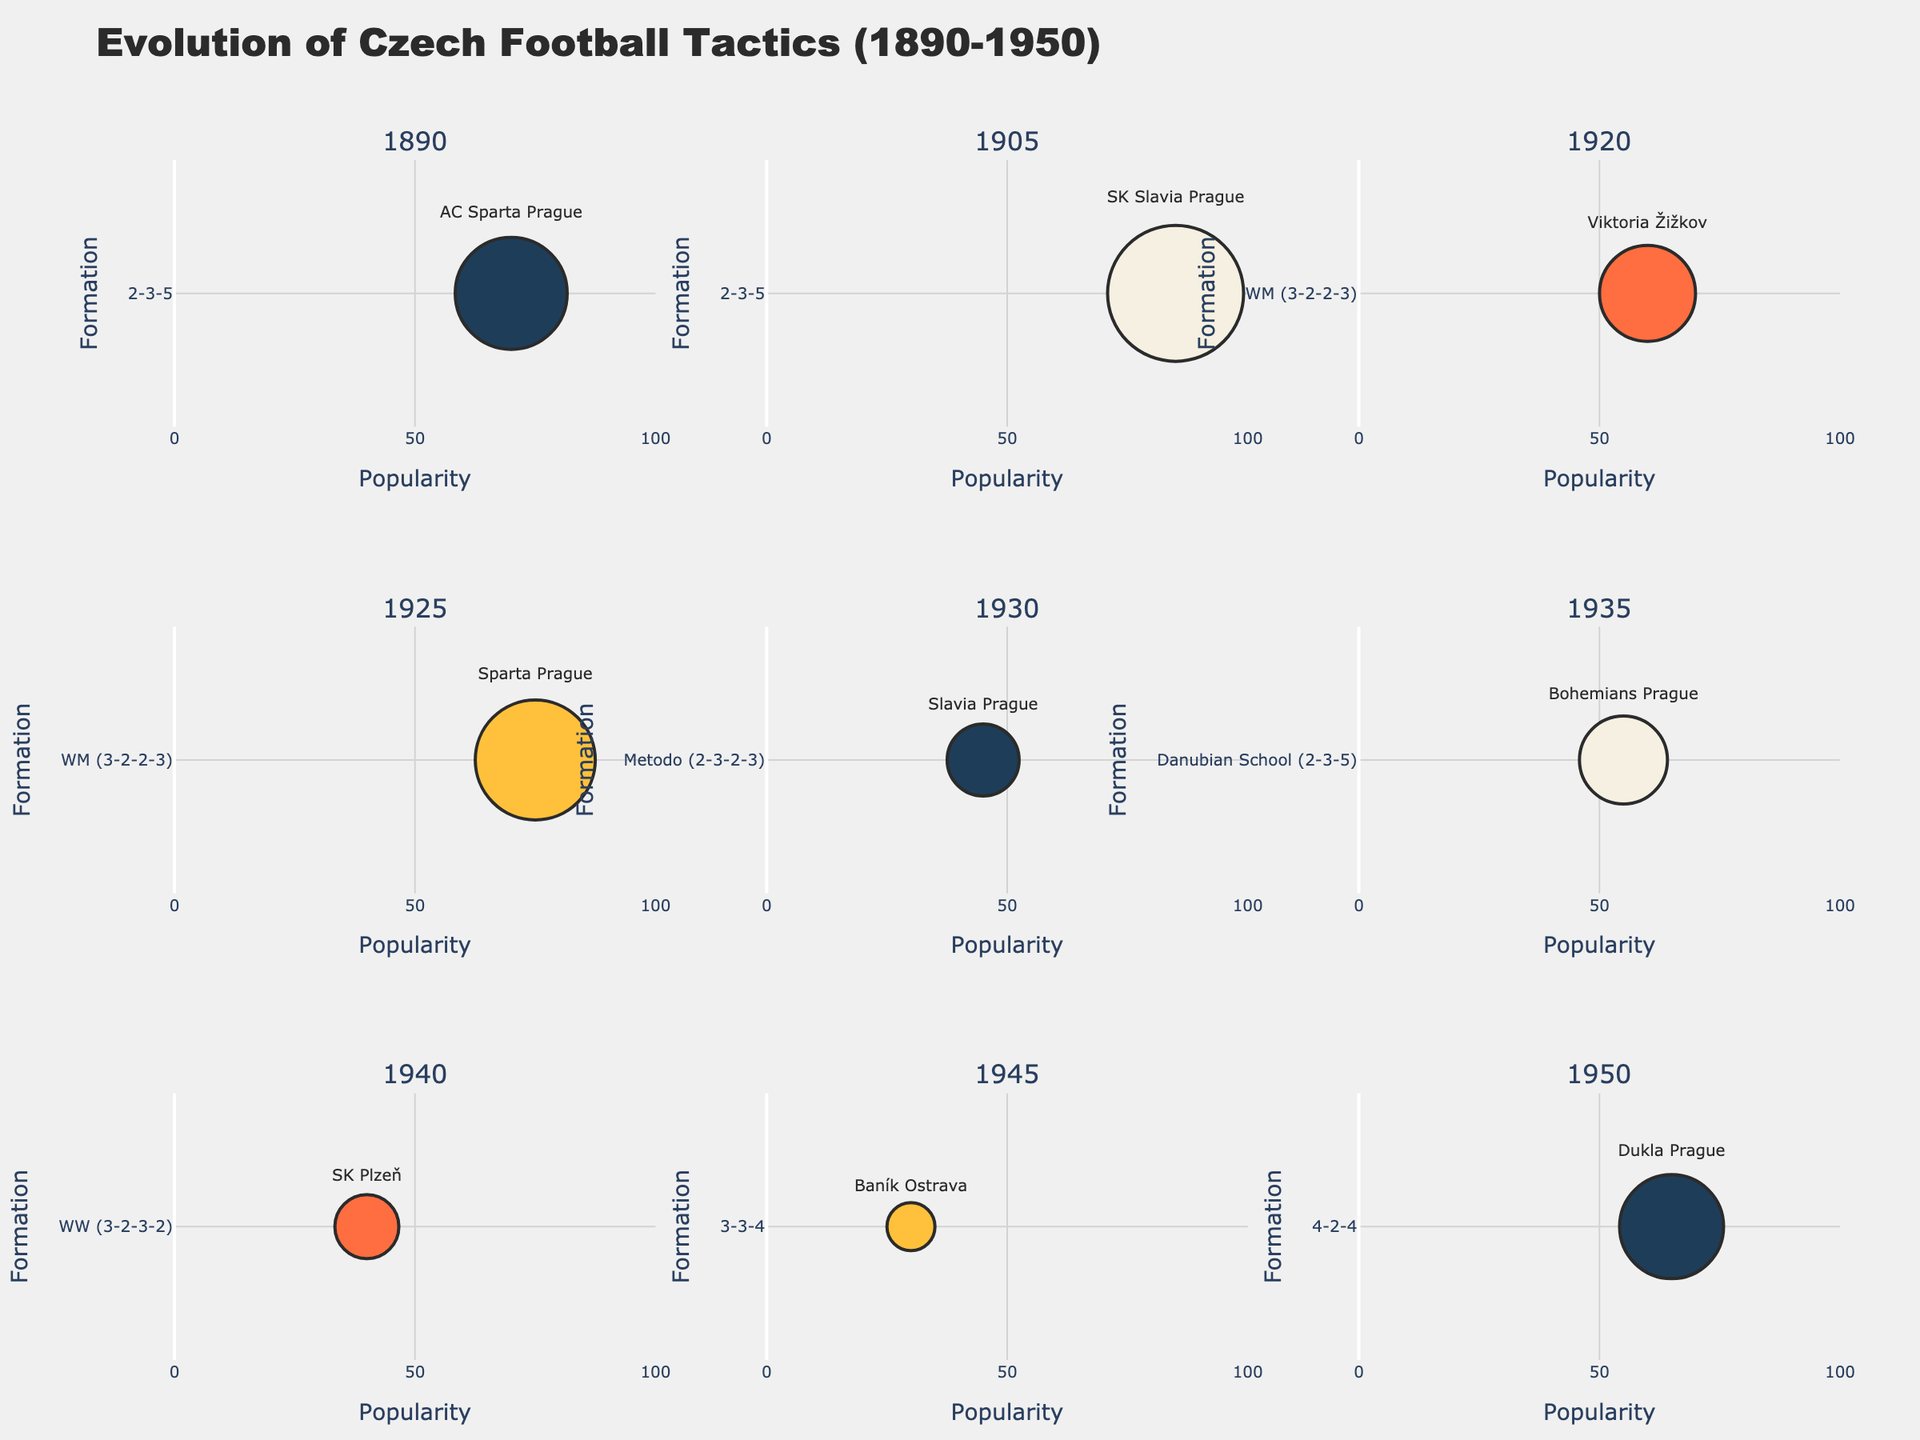What's the title of the figure? The title is typically placed at the top, usually larger and bolder than other text elements.
Answer: Evolution of Czech Football Tactics (1890-1950) Which year had the most popular formation? Look for the largest bubble in the figure, corresponding to the highest value on the x-axis, which represents popularity.
Answer: 1905 What formation was used by Dukla Prague in 1950? Check the text label within the bubble for the year 1950.
Answer: 4-2-4 Which formation was the least popular in 1945? Identify the smallest bubble for the year 1945, which corresponds to the year it represents.
Answer: 3-3-4 What is the sum of popularity ratings for formations used by Sparta Prague in 1890 and 1925? Locate the bubbles for 1890 and 1925 and sum their popularity values (70 and 75).
Answer: 145 Which formation appears in both 1890 and 1935? Compare the formations listed for 1890 and 1935 to find any repetition.
Answer: 2-3-5 Between 1905 and 1920, which formation had higher popularity? Compare the x-axis (popularity value) of the bubbles for 1905 and 1920 to see which one is higher.
Answer: 2-3-5 How does the popularity of the WM (3-2-2-3) formation change from 1920 to 1925? Compare the size of the bubbles and x-axis values for the WM formation in 1920 and 1925.
Answer: It increases What's the average popularity of formations in 1930 and 1950? Sum the popularity values for 1930 (45) and 1950 (65) and divide by 2.
Answer: 55 Which team used the WW (3-2-3-2) formation? Look at the text label within the bubble next to the WW formation.
Answer: SK Plzeň 